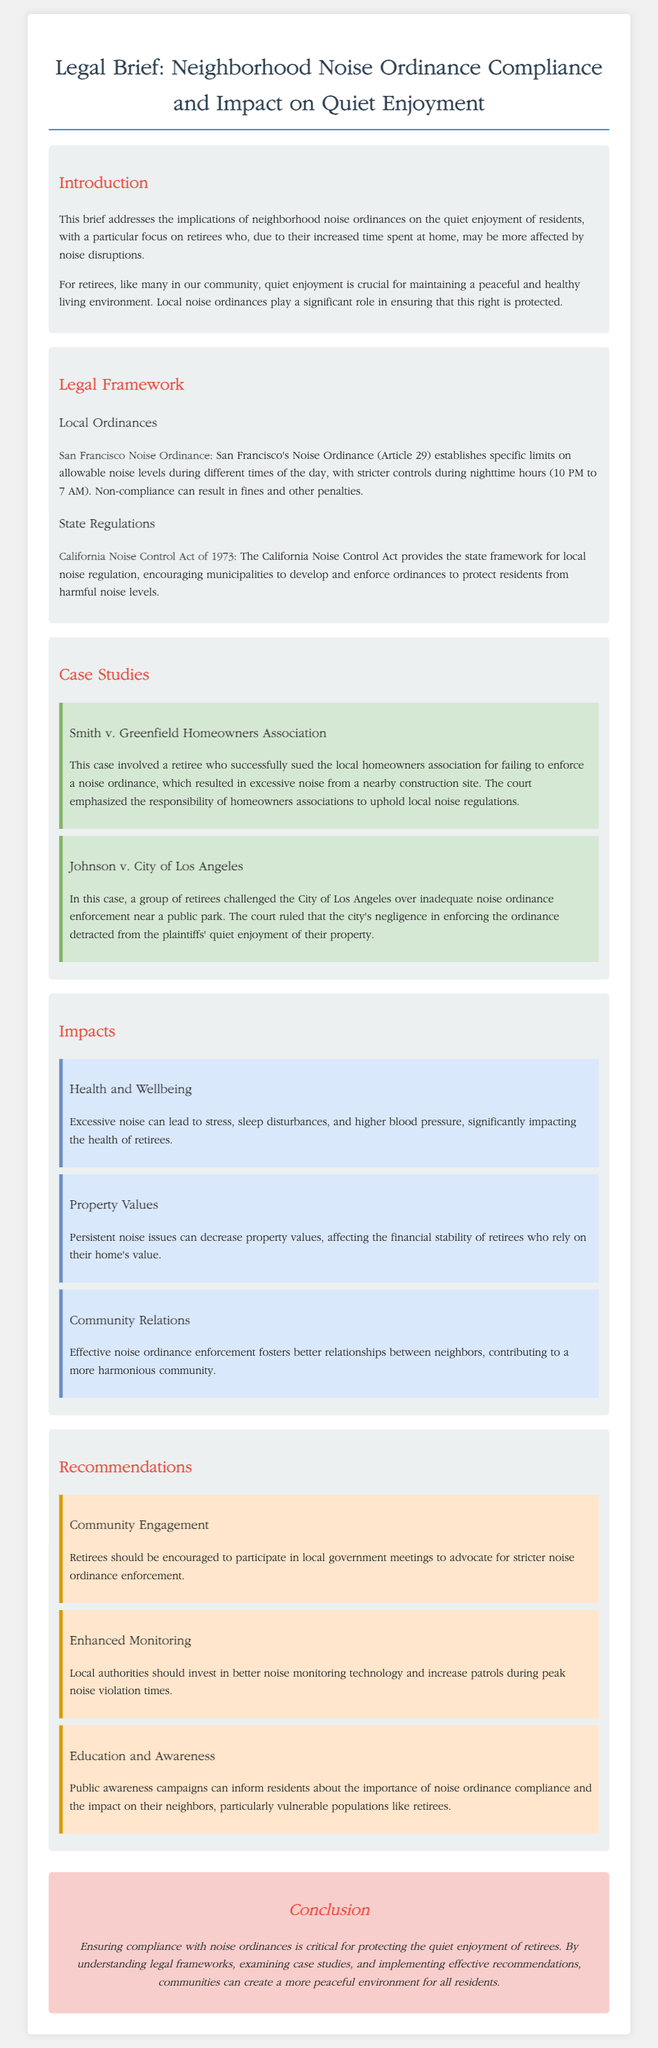What is the title of the legal brief? The title is prominently displayed at the top of the document, providing the main focus of the brief.
Answer: Legal Brief: Neighborhood Noise Ordinance Compliance and Impact on Quiet Enjoyment What ordinance is mentioned for San Francisco? This refers to the specific local noise regulations that are outlined to protect residents from excessive noise.
Answer: San Francisco Noise Ordinance What time does the noise ordinance restrict noise levels to be stricter? This refers to the designated hours when noise levels must be minimized according to the neighborhood regulations.
Answer: 10 PM to 7 AM What impact does excessive noise have on retirees' health? This question addresses the specific health concerns expressed in the document regarding noise disruption.
Answer: Stress, sleep disturbances, and higher blood pressure What case emphasized the responsibility of homeowners associations? This case study illustrates the legal obligations of homeowners associations in enforcing noise regulations.
Answer: Smith v. Greenfield Homeowners Association What recommendation encourages retirees to voice their concerns? This recommendation suggests a proactive approach for retirees to influence local governance regarding noise issues.
Answer: Community Engagement How does noise ordinance compliance affect property values? This point discusses the financial implications of noise disturbances on retirees and their homes.
Answer: Decrease property values What is a key component of the California Noise Control Act? This identifies a significant aspect of the state law that empowers local jurisdictions in noise regulation.
Answer: Encouraging municipalities to develop and enforce ordinances What kind of monitoring is recommended for local authorities? This emphasizes the need for more effective oversight regarding neighborhood noise levels.
Answer: Enhanced Monitoring 